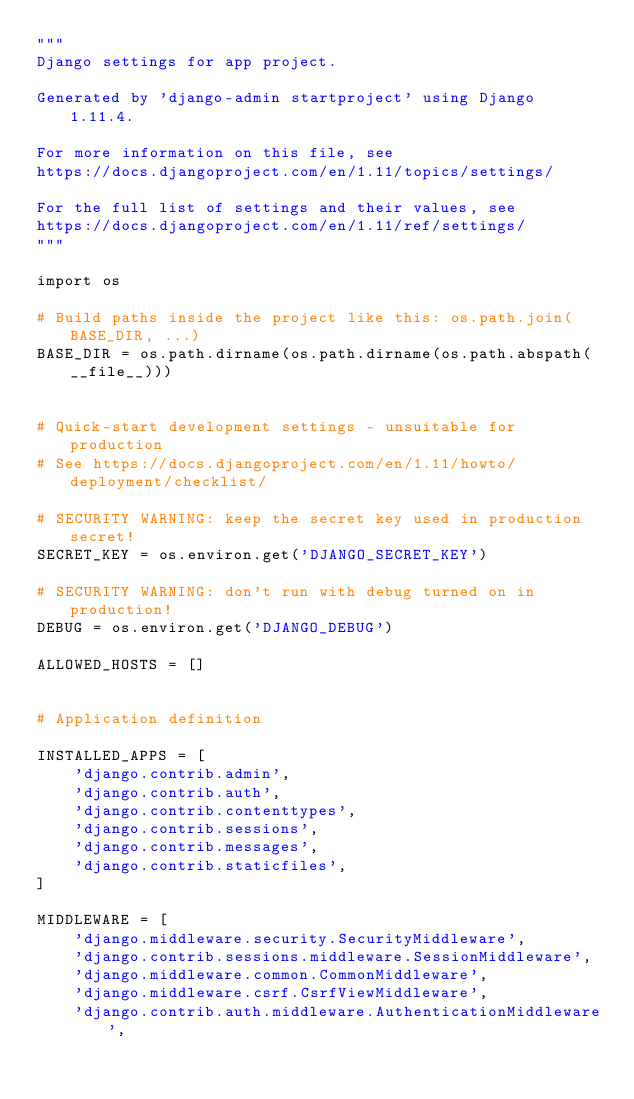<code> <loc_0><loc_0><loc_500><loc_500><_Python_>"""
Django settings for app project.

Generated by 'django-admin startproject' using Django 1.11.4.

For more information on this file, see
https://docs.djangoproject.com/en/1.11/topics/settings/

For the full list of settings and their values, see
https://docs.djangoproject.com/en/1.11/ref/settings/
"""

import os

# Build paths inside the project like this: os.path.join(BASE_DIR, ...)
BASE_DIR = os.path.dirname(os.path.dirname(os.path.abspath(__file__)))


# Quick-start development settings - unsuitable for production
# See https://docs.djangoproject.com/en/1.11/howto/deployment/checklist/

# SECURITY WARNING: keep the secret key used in production secret!
SECRET_KEY = os.environ.get('DJANGO_SECRET_KEY')

# SECURITY WARNING: don't run with debug turned on in production!
DEBUG = os.environ.get('DJANGO_DEBUG')

ALLOWED_HOSTS = []


# Application definition

INSTALLED_APPS = [
    'django.contrib.admin',
    'django.contrib.auth',
    'django.contrib.contenttypes',
    'django.contrib.sessions',
    'django.contrib.messages',
    'django.contrib.staticfiles',
]

MIDDLEWARE = [
    'django.middleware.security.SecurityMiddleware',
    'django.contrib.sessions.middleware.SessionMiddleware',
    'django.middleware.common.CommonMiddleware',
    'django.middleware.csrf.CsrfViewMiddleware',
    'django.contrib.auth.middleware.AuthenticationMiddleware',</code> 